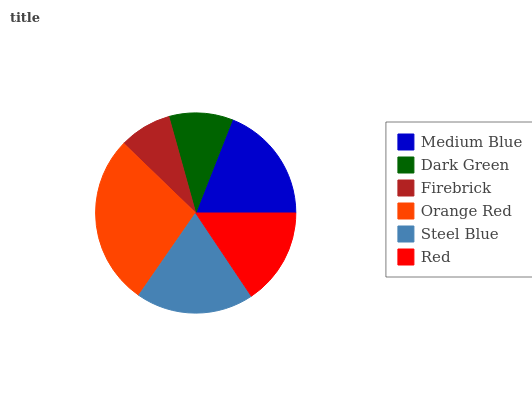Is Firebrick the minimum?
Answer yes or no. Yes. Is Orange Red the maximum?
Answer yes or no. Yes. Is Dark Green the minimum?
Answer yes or no. No. Is Dark Green the maximum?
Answer yes or no. No. Is Medium Blue greater than Dark Green?
Answer yes or no. Yes. Is Dark Green less than Medium Blue?
Answer yes or no. Yes. Is Dark Green greater than Medium Blue?
Answer yes or no. No. Is Medium Blue less than Dark Green?
Answer yes or no. No. Is Steel Blue the high median?
Answer yes or no. Yes. Is Red the low median?
Answer yes or no. Yes. Is Medium Blue the high median?
Answer yes or no. No. Is Medium Blue the low median?
Answer yes or no. No. 